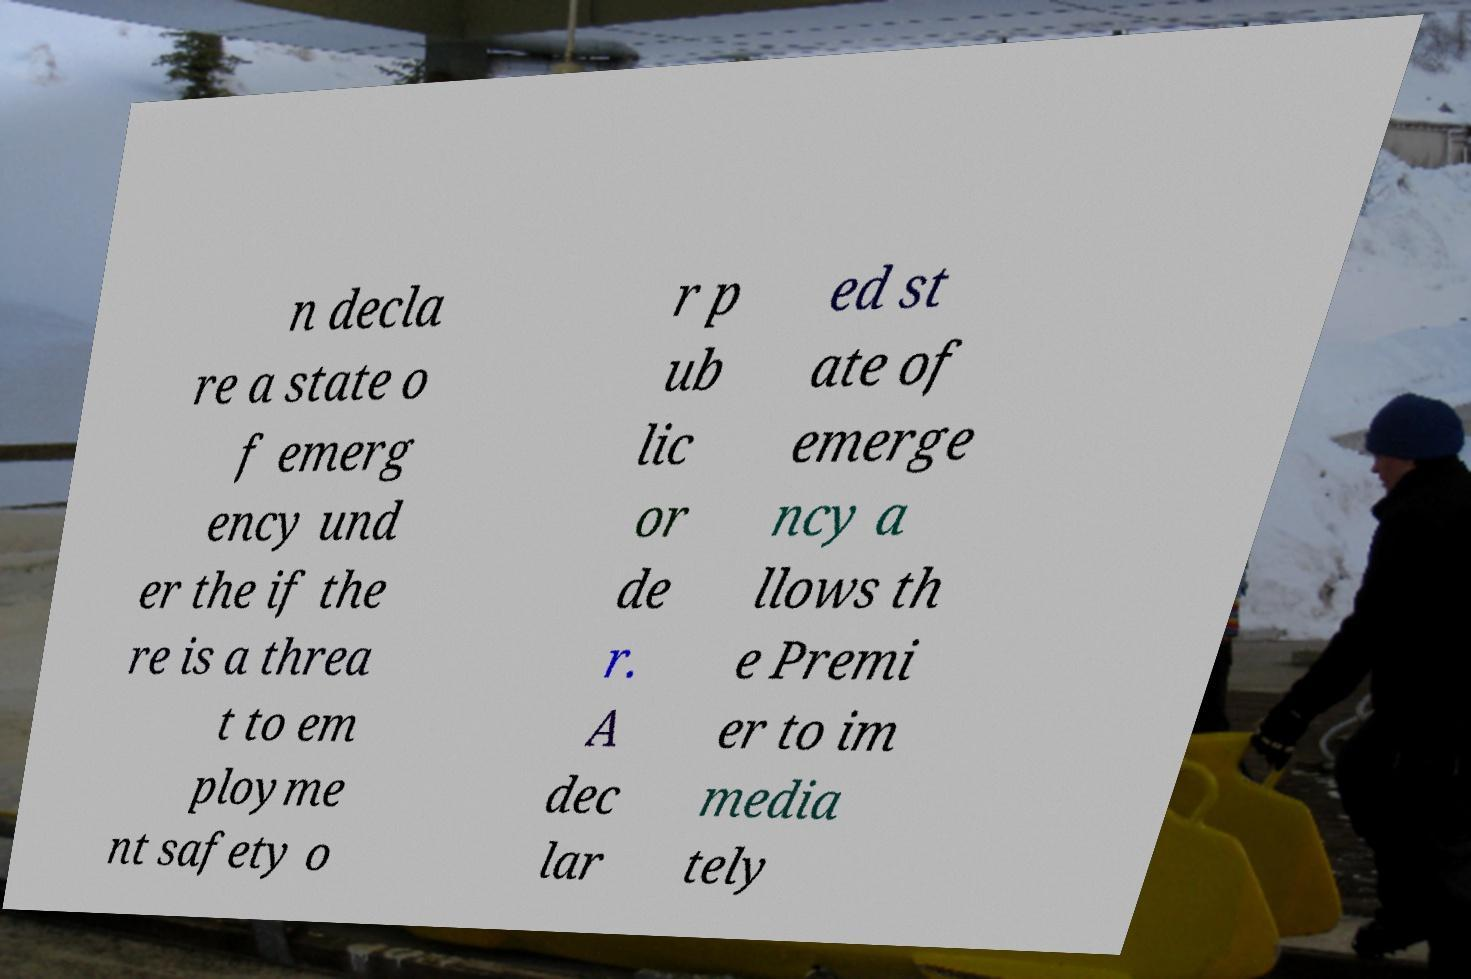I need the written content from this picture converted into text. Can you do that? n decla re a state o f emerg ency und er the if the re is a threa t to em ployme nt safety o r p ub lic or de r. A dec lar ed st ate of emerge ncy a llows th e Premi er to im media tely 